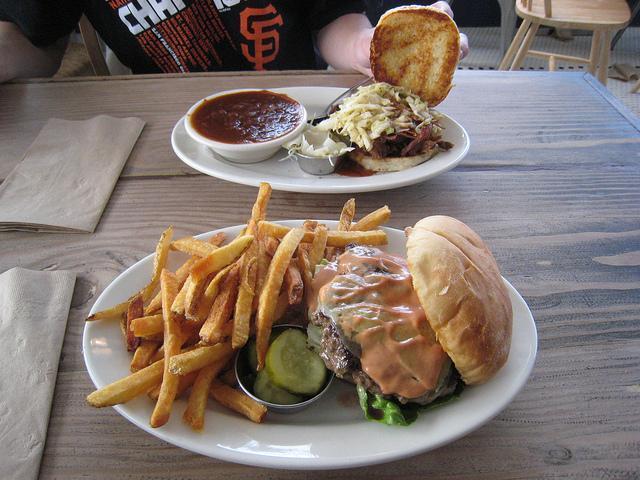How many dining tables are visible?
Give a very brief answer. 1. How many sandwiches are visible?
Give a very brief answer. 2. How many bowls are there?
Give a very brief answer. 2. 